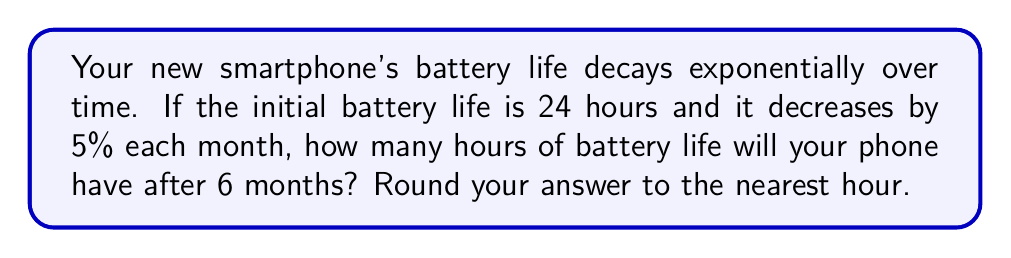What is the answer to this math problem? Let's approach this step-by-step:

1) The initial battery life is 24 hours.

2) The decay rate is 5% = 0.05 per month.

3) We need to find the battery life after 6 months.

4) The formula for exponential decay is:

   $A = A_0 \cdot (1-r)^t$

   Where:
   $A$ is the final amount
   $A_0$ is the initial amount
   $r$ is the decay rate
   $t$ is the time period

5) Plugging in our values:

   $A = 24 \cdot (1-0.05)^6$

6) Let's calculate this:

   $A = 24 \cdot (0.95)^6$
   
   $A = 24 \cdot 0.7351767$
   
   $A = 17.6442408$

7) Rounding to the nearest hour:

   $A \approx 18$ hours
Answer: 18 hours 